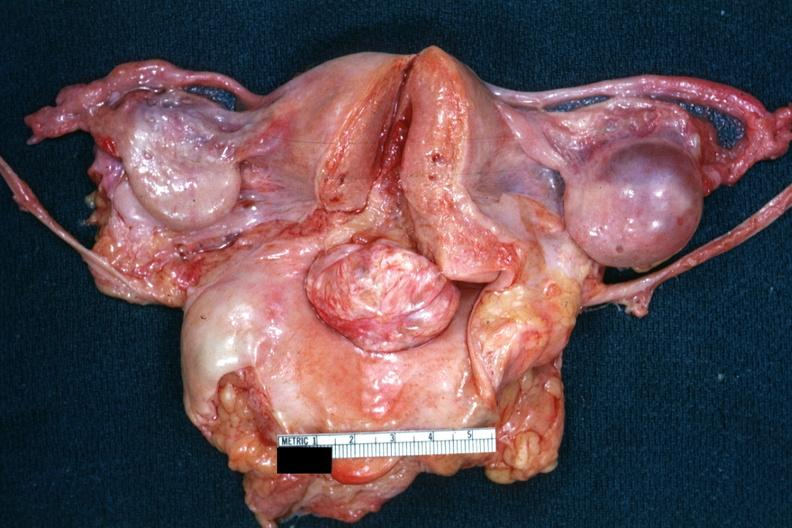what is close-up of cut surface of this myoma?
Answer the question using a single word or phrase. Opened uterus and cervix with large cervical protruding into vagina slide 